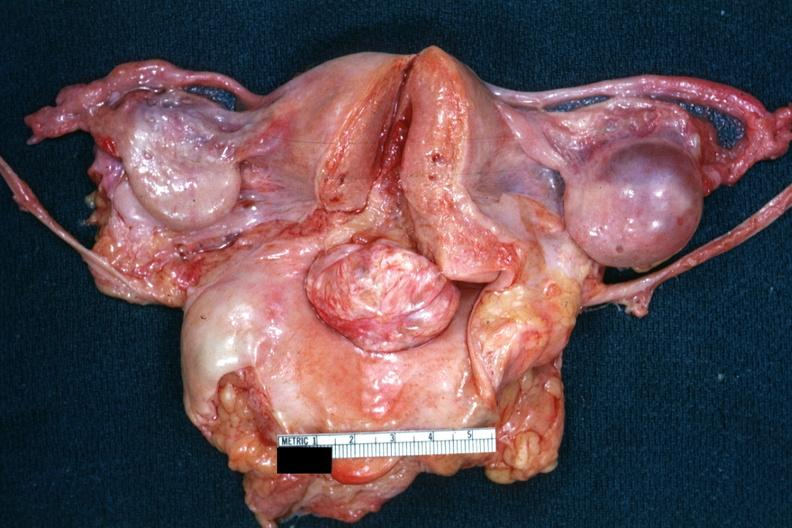what is close-up of cut surface of this myoma?
Answer the question using a single word or phrase. Opened uterus and cervix with large cervical protruding into vagina slide 